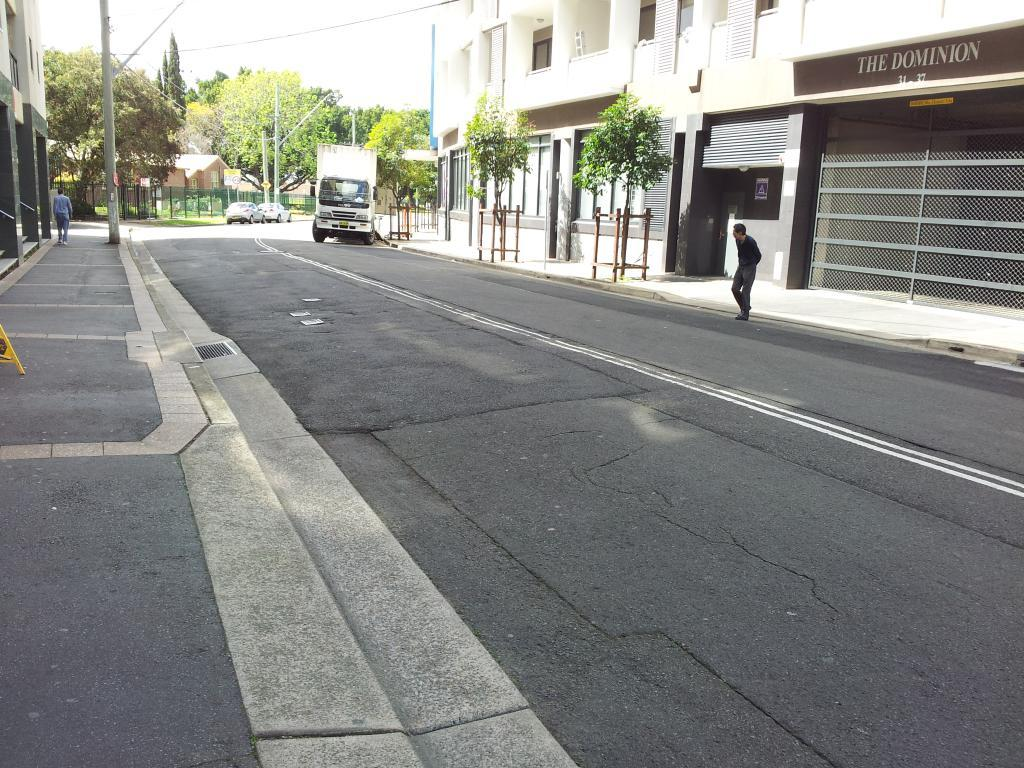What can be seen on the road in the image? There are persons standing on the road in the image. What else is present on the road besides the persons? Motor vehicles are present in the image. What structures can be seen along the road? Street poles, street lights, and buildings are visible in the image. What type of vegetation is present in the image? Plants are visible in the image. What signs are present in the image? Name boards are present in the image. What type of material is visible in the image? Mesh is visible in the image. What part of the natural environment is visible in the image? The sky is visible in the image. What advice is being given to the persons standing on the road in the image? There is no indication in the image that any advice is being given to the persons standing on the road. What type of voyage is being undertaken by the persons in the image? There is no indication in the image that the persons are on a voyage or traveling anywhere. 